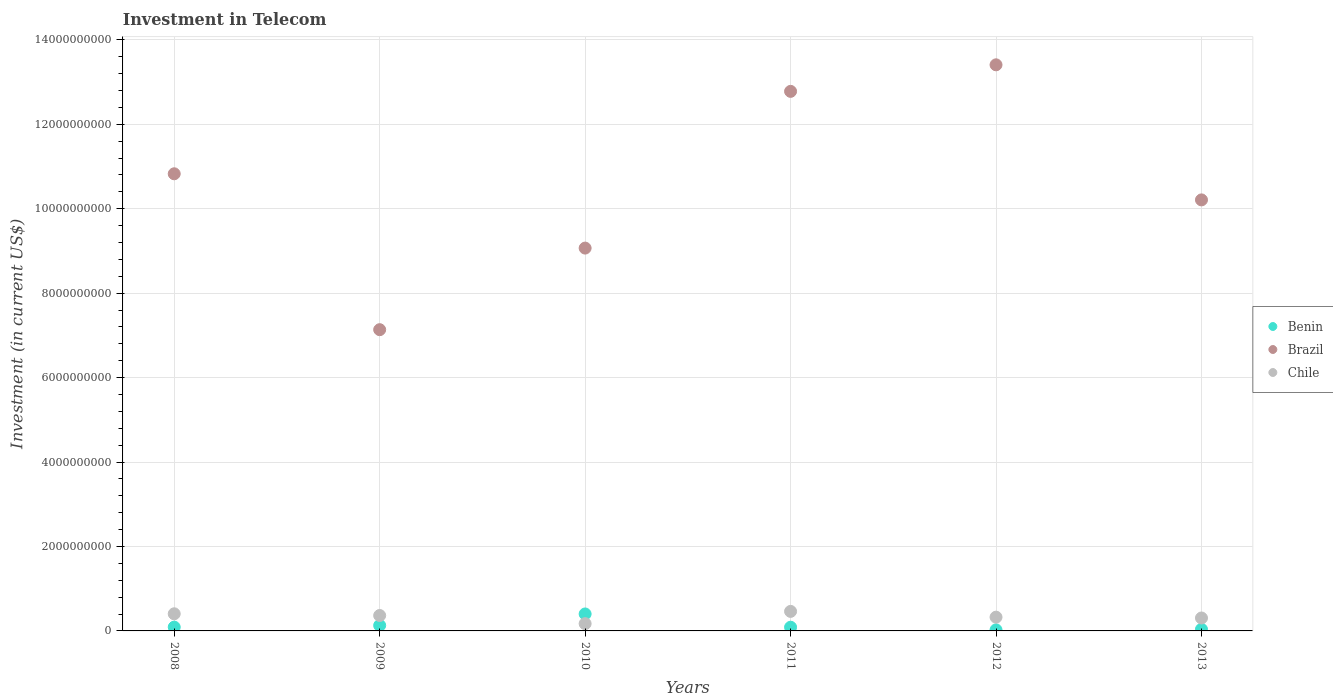How many different coloured dotlines are there?
Give a very brief answer. 3. What is the amount invested in telecom in Benin in 2012?
Make the answer very short. 2.51e+07. Across all years, what is the maximum amount invested in telecom in Chile?
Provide a succinct answer. 4.63e+08. Across all years, what is the minimum amount invested in telecom in Chile?
Offer a very short reply. 1.72e+08. In which year was the amount invested in telecom in Benin maximum?
Make the answer very short. 2010. In which year was the amount invested in telecom in Brazil minimum?
Offer a terse response. 2009. What is the total amount invested in telecom in Benin in the graph?
Keep it short and to the point. 7.73e+08. What is the difference between the amount invested in telecom in Chile in 2008 and that in 2011?
Your answer should be compact. -5.69e+07. What is the difference between the amount invested in telecom in Benin in 2013 and the amount invested in telecom in Chile in 2009?
Provide a succinct answer. -3.27e+08. What is the average amount invested in telecom in Chile per year?
Your answer should be very brief. 3.40e+08. In the year 2013, what is the difference between the amount invested in telecom in Chile and amount invested in telecom in Benin?
Provide a succinct answer. 2.68e+08. In how many years, is the amount invested in telecom in Benin greater than 10800000000 US$?
Give a very brief answer. 0. What is the ratio of the amount invested in telecom in Brazil in 2008 to that in 2012?
Make the answer very short. 0.81. Is the difference between the amount invested in telecom in Chile in 2010 and 2012 greater than the difference between the amount invested in telecom in Benin in 2010 and 2012?
Your answer should be very brief. No. What is the difference between the highest and the second highest amount invested in telecom in Benin?
Ensure brevity in your answer.  2.72e+08. What is the difference between the highest and the lowest amount invested in telecom in Brazil?
Offer a very short reply. 6.27e+09. In how many years, is the amount invested in telecom in Chile greater than the average amount invested in telecom in Chile taken over all years?
Give a very brief answer. 3. Is it the case that in every year, the sum of the amount invested in telecom in Benin and amount invested in telecom in Brazil  is greater than the amount invested in telecom in Chile?
Your answer should be very brief. Yes. Does the amount invested in telecom in Benin monotonically increase over the years?
Ensure brevity in your answer.  No. How many dotlines are there?
Offer a terse response. 3. What is the difference between two consecutive major ticks on the Y-axis?
Provide a succinct answer. 2.00e+09. Are the values on the major ticks of Y-axis written in scientific E-notation?
Keep it short and to the point. No. Does the graph contain any zero values?
Offer a very short reply. No. Where does the legend appear in the graph?
Offer a very short reply. Center right. How are the legend labels stacked?
Provide a succinct answer. Vertical. What is the title of the graph?
Give a very brief answer. Investment in Telecom. Does "Costa Rica" appear as one of the legend labels in the graph?
Give a very brief answer. No. What is the label or title of the X-axis?
Keep it short and to the point. Years. What is the label or title of the Y-axis?
Your answer should be very brief. Investment (in current US$). What is the Investment (in current US$) of Benin in 2008?
Your response must be concise. 8.98e+07. What is the Investment (in current US$) in Brazil in 2008?
Provide a short and direct response. 1.08e+1. What is the Investment (in current US$) of Chile in 2008?
Keep it short and to the point. 4.06e+08. What is the Investment (in current US$) of Benin in 2009?
Give a very brief answer. 1.30e+08. What is the Investment (in current US$) in Brazil in 2009?
Give a very brief answer. 7.14e+09. What is the Investment (in current US$) of Chile in 2009?
Your response must be concise. 3.65e+08. What is the Investment (in current US$) in Benin in 2010?
Provide a succinct answer. 4.02e+08. What is the Investment (in current US$) in Brazil in 2010?
Ensure brevity in your answer.  9.07e+09. What is the Investment (in current US$) of Chile in 2010?
Make the answer very short. 1.72e+08. What is the Investment (in current US$) of Benin in 2011?
Give a very brief answer. 8.77e+07. What is the Investment (in current US$) of Brazil in 2011?
Ensure brevity in your answer.  1.28e+1. What is the Investment (in current US$) of Chile in 2011?
Offer a terse response. 4.63e+08. What is the Investment (in current US$) in Benin in 2012?
Offer a terse response. 2.51e+07. What is the Investment (in current US$) in Brazil in 2012?
Your response must be concise. 1.34e+1. What is the Investment (in current US$) of Chile in 2012?
Offer a very short reply. 3.26e+08. What is the Investment (in current US$) of Benin in 2013?
Offer a very short reply. 3.84e+07. What is the Investment (in current US$) of Brazil in 2013?
Your answer should be compact. 1.02e+1. What is the Investment (in current US$) of Chile in 2013?
Make the answer very short. 3.06e+08. Across all years, what is the maximum Investment (in current US$) of Benin?
Make the answer very short. 4.02e+08. Across all years, what is the maximum Investment (in current US$) in Brazil?
Provide a succinct answer. 1.34e+1. Across all years, what is the maximum Investment (in current US$) of Chile?
Your response must be concise. 4.63e+08. Across all years, what is the minimum Investment (in current US$) in Benin?
Offer a very short reply. 2.51e+07. Across all years, what is the minimum Investment (in current US$) of Brazil?
Give a very brief answer. 7.14e+09. Across all years, what is the minimum Investment (in current US$) of Chile?
Your response must be concise. 1.72e+08. What is the total Investment (in current US$) in Benin in the graph?
Your answer should be very brief. 7.73e+08. What is the total Investment (in current US$) in Brazil in the graph?
Give a very brief answer. 6.34e+1. What is the total Investment (in current US$) of Chile in the graph?
Provide a succinct answer. 2.04e+09. What is the difference between the Investment (in current US$) in Benin in 2008 and that in 2009?
Offer a very short reply. -4.05e+07. What is the difference between the Investment (in current US$) of Brazil in 2008 and that in 2009?
Make the answer very short. 3.69e+09. What is the difference between the Investment (in current US$) of Chile in 2008 and that in 2009?
Provide a succinct answer. 4.04e+07. What is the difference between the Investment (in current US$) in Benin in 2008 and that in 2010?
Provide a succinct answer. -3.12e+08. What is the difference between the Investment (in current US$) of Brazil in 2008 and that in 2010?
Offer a terse response. 1.76e+09. What is the difference between the Investment (in current US$) of Chile in 2008 and that in 2010?
Your answer should be very brief. 2.34e+08. What is the difference between the Investment (in current US$) of Benin in 2008 and that in 2011?
Ensure brevity in your answer.  2.10e+06. What is the difference between the Investment (in current US$) of Brazil in 2008 and that in 2011?
Keep it short and to the point. -1.95e+09. What is the difference between the Investment (in current US$) of Chile in 2008 and that in 2011?
Your answer should be compact. -5.69e+07. What is the difference between the Investment (in current US$) in Benin in 2008 and that in 2012?
Provide a succinct answer. 6.47e+07. What is the difference between the Investment (in current US$) of Brazil in 2008 and that in 2012?
Make the answer very short. -2.58e+09. What is the difference between the Investment (in current US$) in Chile in 2008 and that in 2012?
Ensure brevity in your answer.  7.98e+07. What is the difference between the Investment (in current US$) in Benin in 2008 and that in 2013?
Your answer should be compact. 5.14e+07. What is the difference between the Investment (in current US$) in Brazil in 2008 and that in 2013?
Give a very brief answer. 6.18e+08. What is the difference between the Investment (in current US$) of Chile in 2008 and that in 2013?
Provide a succinct answer. 9.96e+07. What is the difference between the Investment (in current US$) of Benin in 2009 and that in 2010?
Your response must be concise. -2.72e+08. What is the difference between the Investment (in current US$) in Brazil in 2009 and that in 2010?
Ensure brevity in your answer.  -1.93e+09. What is the difference between the Investment (in current US$) of Chile in 2009 and that in 2010?
Offer a very short reply. 1.94e+08. What is the difference between the Investment (in current US$) in Benin in 2009 and that in 2011?
Your response must be concise. 4.26e+07. What is the difference between the Investment (in current US$) in Brazil in 2009 and that in 2011?
Offer a terse response. -5.64e+09. What is the difference between the Investment (in current US$) of Chile in 2009 and that in 2011?
Your answer should be compact. -9.73e+07. What is the difference between the Investment (in current US$) of Benin in 2009 and that in 2012?
Your answer should be compact. 1.05e+08. What is the difference between the Investment (in current US$) in Brazil in 2009 and that in 2012?
Make the answer very short. -6.27e+09. What is the difference between the Investment (in current US$) of Chile in 2009 and that in 2012?
Provide a succinct answer. 3.94e+07. What is the difference between the Investment (in current US$) in Benin in 2009 and that in 2013?
Provide a succinct answer. 9.19e+07. What is the difference between the Investment (in current US$) in Brazil in 2009 and that in 2013?
Keep it short and to the point. -3.07e+09. What is the difference between the Investment (in current US$) of Chile in 2009 and that in 2013?
Your response must be concise. 5.92e+07. What is the difference between the Investment (in current US$) in Benin in 2010 and that in 2011?
Offer a terse response. 3.14e+08. What is the difference between the Investment (in current US$) of Brazil in 2010 and that in 2011?
Your response must be concise. -3.71e+09. What is the difference between the Investment (in current US$) of Chile in 2010 and that in 2011?
Provide a short and direct response. -2.91e+08. What is the difference between the Investment (in current US$) in Benin in 2010 and that in 2012?
Your answer should be very brief. 3.77e+08. What is the difference between the Investment (in current US$) of Brazil in 2010 and that in 2012?
Your answer should be compact. -4.34e+09. What is the difference between the Investment (in current US$) in Chile in 2010 and that in 2012?
Provide a short and direct response. -1.54e+08. What is the difference between the Investment (in current US$) of Benin in 2010 and that in 2013?
Ensure brevity in your answer.  3.64e+08. What is the difference between the Investment (in current US$) in Brazil in 2010 and that in 2013?
Provide a short and direct response. -1.14e+09. What is the difference between the Investment (in current US$) in Chile in 2010 and that in 2013?
Your response must be concise. -1.34e+08. What is the difference between the Investment (in current US$) in Benin in 2011 and that in 2012?
Your answer should be very brief. 6.26e+07. What is the difference between the Investment (in current US$) of Brazil in 2011 and that in 2012?
Make the answer very short. -6.29e+08. What is the difference between the Investment (in current US$) in Chile in 2011 and that in 2012?
Ensure brevity in your answer.  1.37e+08. What is the difference between the Investment (in current US$) in Benin in 2011 and that in 2013?
Your answer should be compact. 4.93e+07. What is the difference between the Investment (in current US$) in Brazil in 2011 and that in 2013?
Ensure brevity in your answer.  2.57e+09. What is the difference between the Investment (in current US$) of Chile in 2011 and that in 2013?
Your response must be concise. 1.56e+08. What is the difference between the Investment (in current US$) in Benin in 2012 and that in 2013?
Keep it short and to the point. -1.33e+07. What is the difference between the Investment (in current US$) in Brazil in 2012 and that in 2013?
Offer a terse response. 3.20e+09. What is the difference between the Investment (in current US$) of Chile in 2012 and that in 2013?
Your answer should be very brief. 1.98e+07. What is the difference between the Investment (in current US$) of Benin in 2008 and the Investment (in current US$) of Brazil in 2009?
Give a very brief answer. -7.05e+09. What is the difference between the Investment (in current US$) of Benin in 2008 and the Investment (in current US$) of Chile in 2009?
Your answer should be compact. -2.76e+08. What is the difference between the Investment (in current US$) of Brazil in 2008 and the Investment (in current US$) of Chile in 2009?
Give a very brief answer. 1.05e+1. What is the difference between the Investment (in current US$) of Benin in 2008 and the Investment (in current US$) of Brazil in 2010?
Your answer should be very brief. -8.98e+09. What is the difference between the Investment (in current US$) in Benin in 2008 and the Investment (in current US$) in Chile in 2010?
Provide a short and direct response. -8.20e+07. What is the difference between the Investment (in current US$) in Brazil in 2008 and the Investment (in current US$) in Chile in 2010?
Keep it short and to the point. 1.07e+1. What is the difference between the Investment (in current US$) in Benin in 2008 and the Investment (in current US$) in Brazil in 2011?
Your answer should be compact. -1.27e+1. What is the difference between the Investment (in current US$) of Benin in 2008 and the Investment (in current US$) of Chile in 2011?
Offer a terse response. -3.73e+08. What is the difference between the Investment (in current US$) of Brazil in 2008 and the Investment (in current US$) of Chile in 2011?
Offer a terse response. 1.04e+1. What is the difference between the Investment (in current US$) in Benin in 2008 and the Investment (in current US$) in Brazil in 2012?
Make the answer very short. -1.33e+1. What is the difference between the Investment (in current US$) of Benin in 2008 and the Investment (in current US$) of Chile in 2012?
Your answer should be very brief. -2.36e+08. What is the difference between the Investment (in current US$) in Brazil in 2008 and the Investment (in current US$) in Chile in 2012?
Your response must be concise. 1.05e+1. What is the difference between the Investment (in current US$) in Benin in 2008 and the Investment (in current US$) in Brazil in 2013?
Ensure brevity in your answer.  -1.01e+1. What is the difference between the Investment (in current US$) of Benin in 2008 and the Investment (in current US$) of Chile in 2013?
Provide a short and direct response. -2.16e+08. What is the difference between the Investment (in current US$) of Brazil in 2008 and the Investment (in current US$) of Chile in 2013?
Your answer should be compact. 1.05e+1. What is the difference between the Investment (in current US$) in Benin in 2009 and the Investment (in current US$) in Brazil in 2010?
Ensure brevity in your answer.  -8.94e+09. What is the difference between the Investment (in current US$) in Benin in 2009 and the Investment (in current US$) in Chile in 2010?
Offer a very short reply. -4.15e+07. What is the difference between the Investment (in current US$) of Brazil in 2009 and the Investment (in current US$) of Chile in 2010?
Ensure brevity in your answer.  6.96e+09. What is the difference between the Investment (in current US$) in Benin in 2009 and the Investment (in current US$) in Brazil in 2011?
Make the answer very short. -1.27e+1. What is the difference between the Investment (in current US$) in Benin in 2009 and the Investment (in current US$) in Chile in 2011?
Give a very brief answer. -3.32e+08. What is the difference between the Investment (in current US$) in Brazil in 2009 and the Investment (in current US$) in Chile in 2011?
Provide a succinct answer. 6.67e+09. What is the difference between the Investment (in current US$) of Benin in 2009 and the Investment (in current US$) of Brazil in 2012?
Your answer should be compact. -1.33e+1. What is the difference between the Investment (in current US$) in Benin in 2009 and the Investment (in current US$) in Chile in 2012?
Offer a very short reply. -1.96e+08. What is the difference between the Investment (in current US$) in Brazil in 2009 and the Investment (in current US$) in Chile in 2012?
Give a very brief answer. 6.81e+09. What is the difference between the Investment (in current US$) of Benin in 2009 and the Investment (in current US$) of Brazil in 2013?
Provide a short and direct response. -1.01e+1. What is the difference between the Investment (in current US$) of Benin in 2009 and the Investment (in current US$) of Chile in 2013?
Your answer should be very brief. -1.76e+08. What is the difference between the Investment (in current US$) of Brazil in 2009 and the Investment (in current US$) of Chile in 2013?
Provide a succinct answer. 6.83e+09. What is the difference between the Investment (in current US$) of Benin in 2010 and the Investment (in current US$) of Brazil in 2011?
Your answer should be compact. -1.24e+1. What is the difference between the Investment (in current US$) in Benin in 2010 and the Investment (in current US$) in Chile in 2011?
Your response must be concise. -6.07e+07. What is the difference between the Investment (in current US$) of Brazil in 2010 and the Investment (in current US$) of Chile in 2011?
Offer a terse response. 8.61e+09. What is the difference between the Investment (in current US$) of Benin in 2010 and the Investment (in current US$) of Brazil in 2012?
Keep it short and to the point. -1.30e+1. What is the difference between the Investment (in current US$) in Benin in 2010 and the Investment (in current US$) in Chile in 2012?
Your answer should be very brief. 7.60e+07. What is the difference between the Investment (in current US$) of Brazil in 2010 and the Investment (in current US$) of Chile in 2012?
Make the answer very short. 8.74e+09. What is the difference between the Investment (in current US$) of Benin in 2010 and the Investment (in current US$) of Brazil in 2013?
Make the answer very short. -9.81e+09. What is the difference between the Investment (in current US$) in Benin in 2010 and the Investment (in current US$) in Chile in 2013?
Offer a terse response. 9.58e+07. What is the difference between the Investment (in current US$) of Brazil in 2010 and the Investment (in current US$) of Chile in 2013?
Make the answer very short. 8.76e+09. What is the difference between the Investment (in current US$) in Benin in 2011 and the Investment (in current US$) in Brazil in 2012?
Provide a succinct answer. -1.33e+1. What is the difference between the Investment (in current US$) in Benin in 2011 and the Investment (in current US$) in Chile in 2012?
Ensure brevity in your answer.  -2.38e+08. What is the difference between the Investment (in current US$) in Brazil in 2011 and the Investment (in current US$) in Chile in 2012?
Offer a terse response. 1.25e+1. What is the difference between the Investment (in current US$) in Benin in 2011 and the Investment (in current US$) in Brazil in 2013?
Make the answer very short. -1.01e+1. What is the difference between the Investment (in current US$) in Benin in 2011 and the Investment (in current US$) in Chile in 2013?
Your answer should be very brief. -2.18e+08. What is the difference between the Investment (in current US$) of Brazil in 2011 and the Investment (in current US$) of Chile in 2013?
Keep it short and to the point. 1.25e+1. What is the difference between the Investment (in current US$) of Benin in 2012 and the Investment (in current US$) of Brazil in 2013?
Your answer should be compact. -1.02e+1. What is the difference between the Investment (in current US$) of Benin in 2012 and the Investment (in current US$) of Chile in 2013?
Offer a terse response. -2.81e+08. What is the difference between the Investment (in current US$) in Brazil in 2012 and the Investment (in current US$) in Chile in 2013?
Offer a very short reply. 1.31e+1. What is the average Investment (in current US$) of Benin per year?
Keep it short and to the point. 1.29e+08. What is the average Investment (in current US$) of Brazil per year?
Offer a terse response. 1.06e+1. What is the average Investment (in current US$) of Chile per year?
Offer a terse response. 3.40e+08. In the year 2008, what is the difference between the Investment (in current US$) in Benin and Investment (in current US$) in Brazil?
Make the answer very short. -1.07e+1. In the year 2008, what is the difference between the Investment (in current US$) in Benin and Investment (in current US$) in Chile?
Your answer should be compact. -3.16e+08. In the year 2008, what is the difference between the Investment (in current US$) of Brazil and Investment (in current US$) of Chile?
Offer a terse response. 1.04e+1. In the year 2009, what is the difference between the Investment (in current US$) of Benin and Investment (in current US$) of Brazil?
Make the answer very short. -7.01e+09. In the year 2009, what is the difference between the Investment (in current US$) of Benin and Investment (in current US$) of Chile?
Ensure brevity in your answer.  -2.35e+08. In the year 2009, what is the difference between the Investment (in current US$) in Brazil and Investment (in current US$) in Chile?
Your answer should be compact. 6.77e+09. In the year 2010, what is the difference between the Investment (in current US$) of Benin and Investment (in current US$) of Brazil?
Offer a very short reply. -8.67e+09. In the year 2010, what is the difference between the Investment (in current US$) of Benin and Investment (in current US$) of Chile?
Make the answer very short. 2.30e+08. In the year 2010, what is the difference between the Investment (in current US$) of Brazil and Investment (in current US$) of Chile?
Your response must be concise. 8.90e+09. In the year 2011, what is the difference between the Investment (in current US$) in Benin and Investment (in current US$) in Brazil?
Provide a short and direct response. -1.27e+1. In the year 2011, what is the difference between the Investment (in current US$) in Benin and Investment (in current US$) in Chile?
Ensure brevity in your answer.  -3.75e+08. In the year 2011, what is the difference between the Investment (in current US$) of Brazil and Investment (in current US$) of Chile?
Ensure brevity in your answer.  1.23e+1. In the year 2012, what is the difference between the Investment (in current US$) in Benin and Investment (in current US$) in Brazil?
Keep it short and to the point. -1.34e+1. In the year 2012, what is the difference between the Investment (in current US$) in Benin and Investment (in current US$) in Chile?
Give a very brief answer. -3.01e+08. In the year 2012, what is the difference between the Investment (in current US$) in Brazil and Investment (in current US$) in Chile?
Offer a very short reply. 1.31e+1. In the year 2013, what is the difference between the Investment (in current US$) in Benin and Investment (in current US$) in Brazil?
Give a very brief answer. -1.02e+1. In the year 2013, what is the difference between the Investment (in current US$) of Benin and Investment (in current US$) of Chile?
Offer a terse response. -2.68e+08. In the year 2013, what is the difference between the Investment (in current US$) in Brazil and Investment (in current US$) in Chile?
Offer a very short reply. 9.90e+09. What is the ratio of the Investment (in current US$) of Benin in 2008 to that in 2009?
Ensure brevity in your answer.  0.69. What is the ratio of the Investment (in current US$) of Brazil in 2008 to that in 2009?
Your answer should be compact. 1.52. What is the ratio of the Investment (in current US$) in Chile in 2008 to that in 2009?
Offer a very short reply. 1.11. What is the ratio of the Investment (in current US$) of Benin in 2008 to that in 2010?
Keep it short and to the point. 0.22. What is the ratio of the Investment (in current US$) of Brazil in 2008 to that in 2010?
Ensure brevity in your answer.  1.19. What is the ratio of the Investment (in current US$) of Chile in 2008 to that in 2010?
Your response must be concise. 2.36. What is the ratio of the Investment (in current US$) of Benin in 2008 to that in 2011?
Your response must be concise. 1.02. What is the ratio of the Investment (in current US$) in Brazil in 2008 to that in 2011?
Your answer should be compact. 0.85. What is the ratio of the Investment (in current US$) in Chile in 2008 to that in 2011?
Ensure brevity in your answer.  0.88. What is the ratio of the Investment (in current US$) in Benin in 2008 to that in 2012?
Your response must be concise. 3.58. What is the ratio of the Investment (in current US$) in Brazil in 2008 to that in 2012?
Offer a terse response. 0.81. What is the ratio of the Investment (in current US$) in Chile in 2008 to that in 2012?
Your answer should be very brief. 1.24. What is the ratio of the Investment (in current US$) in Benin in 2008 to that in 2013?
Ensure brevity in your answer.  2.34. What is the ratio of the Investment (in current US$) in Brazil in 2008 to that in 2013?
Your response must be concise. 1.06. What is the ratio of the Investment (in current US$) of Chile in 2008 to that in 2013?
Ensure brevity in your answer.  1.33. What is the ratio of the Investment (in current US$) of Benin in 2009 to that in 2010?
Give a very brief answer. 0.32. What is the ratio of the Investment (in current US$) in Brazil in 2009 to that in 2010?
Offer a terse response. 0.79. What is the ratio of the Investment (in current US$) of Chile in 2009 to that in 2010?
Ensure brevity in your answer.  2.13. What is the ratio of the Investment (in current US$) in Benin in 2009 to that in 2011?
Make the answer very short. 1.49. What is the ratio of the Investment (in current US$) of Brazil in 2009 to that in 2011?
Your response must be concise. 0.56. What is the ratio of the Investment (in current US$) in Chile in 2009 to that in 2011?
Your response must be concise. 0.79. What is the ratio of the Investment (in current US$) in Benin in 2009 to that in 2012?
Provide a succinct answer. 5.19. What is the ratio of the Investment (in current US$) of Brazil in 2009 to that in 2012?
Offer a very short reply. 0.53. What is the ratio of the Investment (in current US$) of Chile in 2009 to that in 2012?
Give a very brief answer. 1.12. What is the ratio of the Investment (in current US$) of Benin in 2009 to that in 2013?
Offer a terse response. 3.39. What is the ratio of the Investment (in current US$) of Brazil in 2009 to that in 2013?
Ensure brevity in your answer.  0.7. What is the ratio of the Investment (in current US$) of Chile in 2009 to that in 2013?
Give a very brief answer. 1.19. What is the ratio of the Investment (in current US$) in Benin in 2010 to that in 2011?
Give a very brief answer. 4.58. What is the ratio of the Investment (in current US$) in Brazil in 2010 to that in 2011?
Provide a succinct answer. 0.71. What is the ratio of the Investment (in current US$) of Chile in 2010 to that in 2011?
Your answer should be very brief. 0.37. What is the ratio of the Investment (in current US$) in Benin in 2010 to that in 2012?
Give a very brief answer. 16.01. What is the ratio of the Investment (in current US$) in Brazil in 2010 to that in 2012?
Offer a terse response. 0.68. What is the ratio of the Investment (in current US$) of Chile in 2010 to that in 2012?
Make the answer very short. 0.53. What is the ratio of the Investment (in current US$) of Benin in 2010 to that in 2013?
Your response must be concise. 10.47. What is the ratio of the Investment (in current US$) in Brazil in 2010 to that in 2013?
Provide a succinct answer. 0.89. What is the ratio of the Investment (in current US$) in Chile in 2010 to that in 2013?
Provide a succinct answer. 0.56. What is the ratio of the Investment (in current US$) of Benin in 2011 to that in 2012?
Offer a terse response. 3.49. What is the ratio of the Investment (in current US$) in Brazil in 2011 to that in 2012?
Provide a succinct answer. 0.95. What is the ratio of the Investment (in current US$) in Chile in 2011 to that in 2012?
Offer a terse response. 1.42. What is the ratio of the Investment (in current US$) in Benin in 2011 to that in 2013?
Give a very brief answer. 2.28. What is the ratio of the Investment (in current US$) of Brazil in 2011 to that in 2013?
Offer a very short reply. 1.25. What is the ratio of the Investment (in current US$) of Chile in 2011 to that in 2013?
Provide a succinct answer. 1.51. What is the ratio of the Investment (in current US$) in Benin in 2012 to that in 2013?
Ensure brevity in your answer.  0.65. What is the ratio of the Investment (in current US$) of Brazil in 2012 to that in 2013?
Keep it short and to the point. 1.31. What is the ratio of the Investment (in current US$) of Chile in 2012 to that in 2013?
Your answer should be compact. 1.06. What is the difference between the highest and the second highest Investment (in current US$) of Benin?
Provide a short and direct response. 2.72e+08. What is the difference between the highest and the second highest Investment (in current US$) of Brazil?
Your response must be concise. 6.29e+08. What is the difference between the highest and the second highest Investment (in current US$) of Chile?
Provide a succinct answer. 5.69e+07. What is the difference between the highest and the lowest Investment (in current US$) in Benin?
Offer a terse response. 3.77e+08. What is the difference between the highest and the lowest Investment (in current US$) of Brazil?
Offer a terse response. 6.27e+09. What is the difference between the highest and the lowest Investment (in current US$) in Chile?
Make the answer very short. 2.91e+08. 